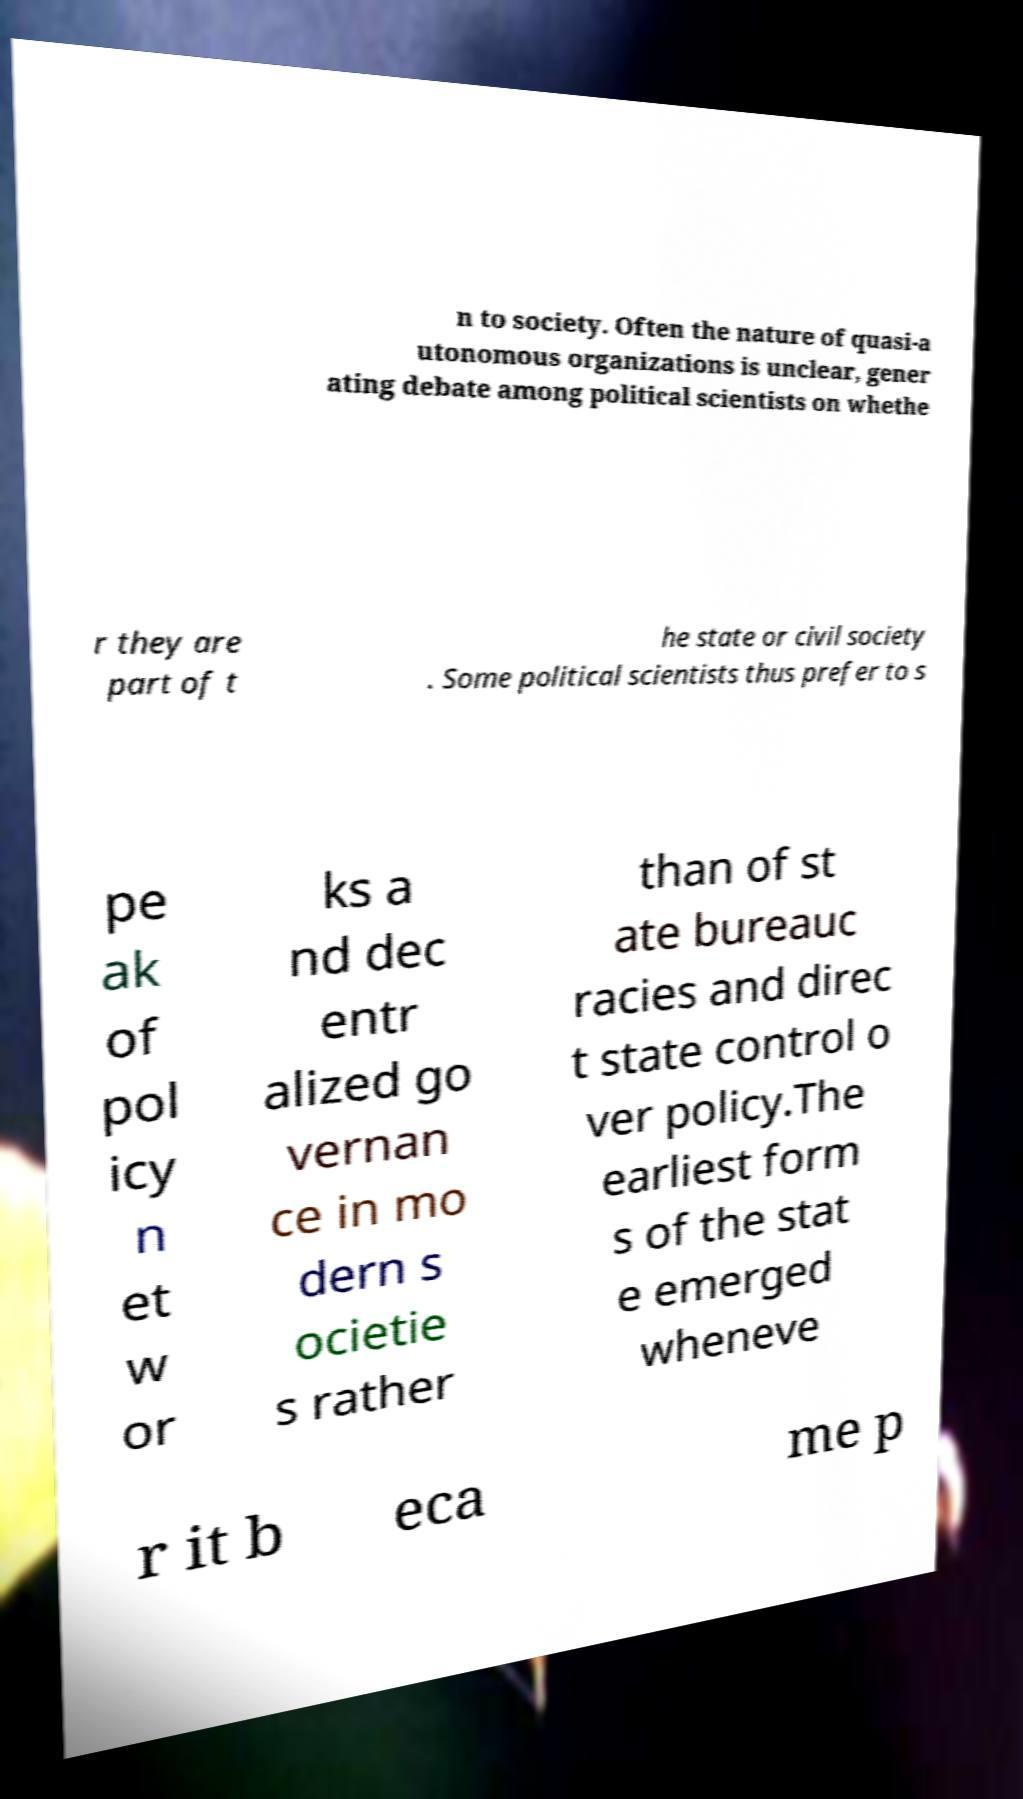Can you accurately transcribe the text from the provided image for me? n to society. Often the nature of quasi-a utonomous organizations is unclear, gener ating debate among political scientists on whethe r they are part of t he state or civil society . Some political scientists thus prefer to s pe ak of pol icy n et w or ks a nd dec entr alized go vernan ce in mo dern s ocietie s rather than of st ate bureauc racies and direc t state control o ver policy.The earliest form s of the stat e emerged wheneve r it b eca me p 